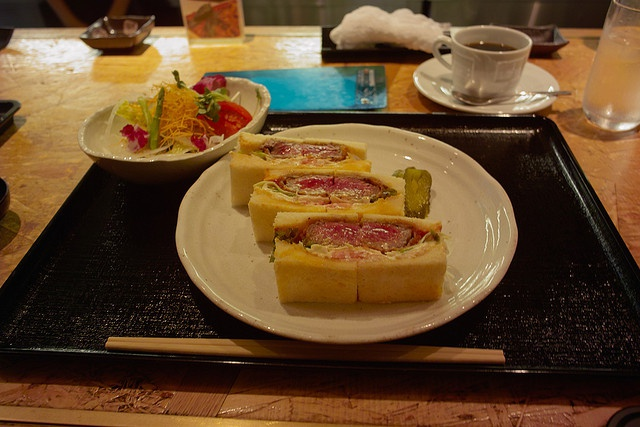Describe the objects in this image and their specific colors. I can see dining table in black, brown, tan, and maroon tones, sandwich in black, olive, maroon, and tan tones, bowl in black, olive, tan, and maroon tones, sandwich in black, olive, orange, maroon, and tan tones, and cup in black, tan, and maroon tones in this image. 